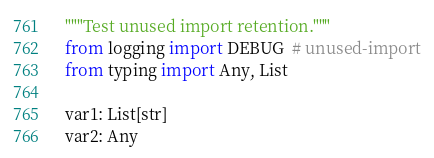Convert code to text. <code><loc_0><loc_0><loc_500><loc_500><_Python_>"""Test unused import retention."""
from logging import DEBUG  # unused-import
from typing import Any, List

var1: List[str]
var2: Any
</code> 